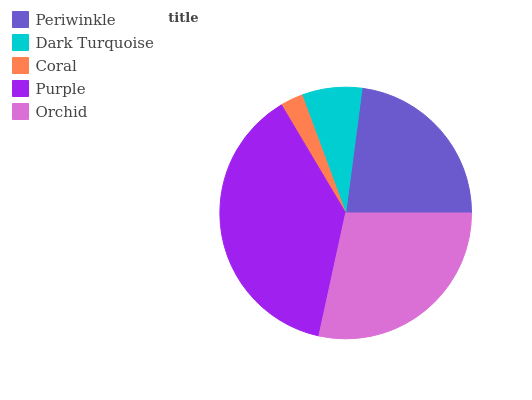Is Coral the minimum?
Answer yes or no. Yes. Is Purple the maximum?
Answer yes or no. Yes. Is Dark Turquoise the minimum?
Answer yes or no. No. Is Dark Turquoise the maximum?
Answer yes or no. No. Is Periwinkle greater than Dark Turquoise?
Answer yes or no. Yes. Is Dark Turquoise less than Periwinkle?
Answer yes or no. Yes. Is Dark Turquoise greater than Periwinkle?
Answer yes or no. No. Is Periwinkle less than Dark Turquoise?
Answer yes or no. No. Is Periwinkle the high median?
Answer yes or no. Yes. Is Periwinkle the low median?
Answer yes or no. Yes. Is Purple the high median?
Answer yes or no. No. Is Dark Turquoise the low median?
Answer yes or no. No. 